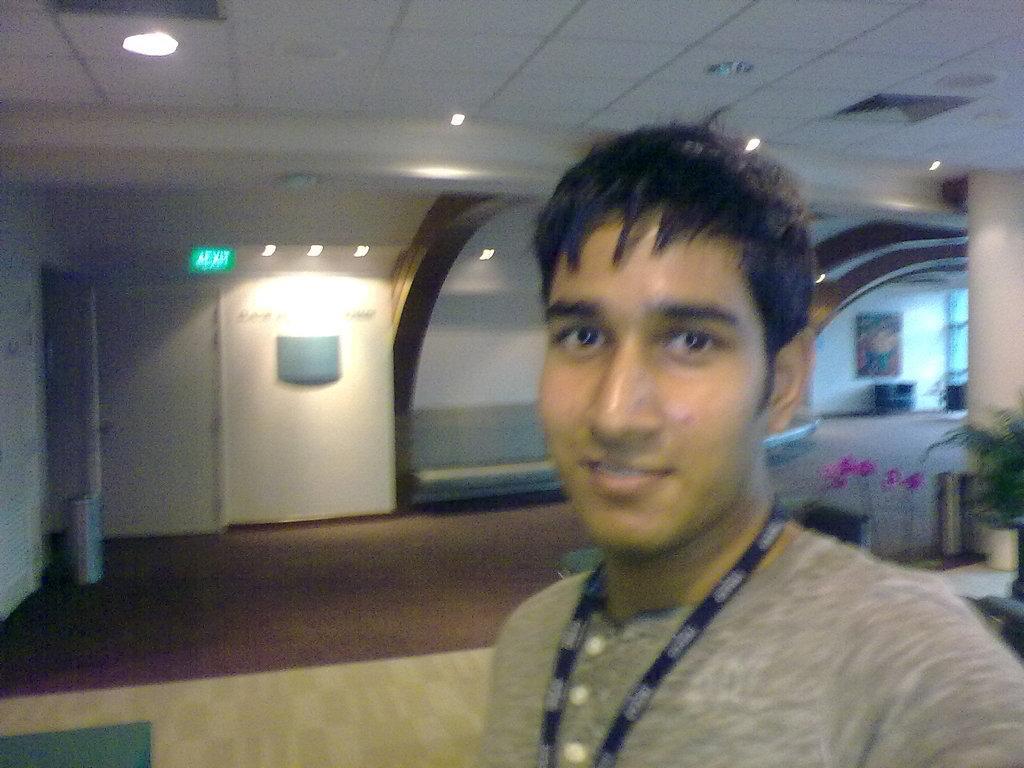In one or two sentences, can you explain what this image depicts? In this image I can see the person. I can see few flowerpots, door, lights, ceiling, wall and the floor. 